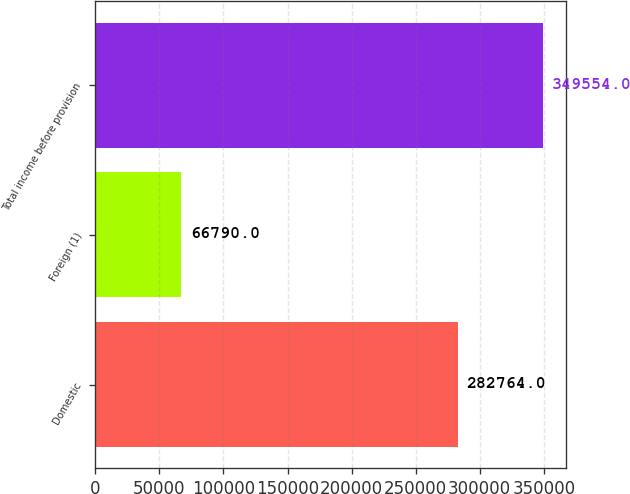Convert chart to OTSL. <chart><loc_0><loc_0><loc_500><loc_500><bar_chart><fcel>Domestic<fcel>Foreign (1)<fcel>Total income before provision<nl><fcel>282764<fcel>66790<fcel>349554<nl></chart> 